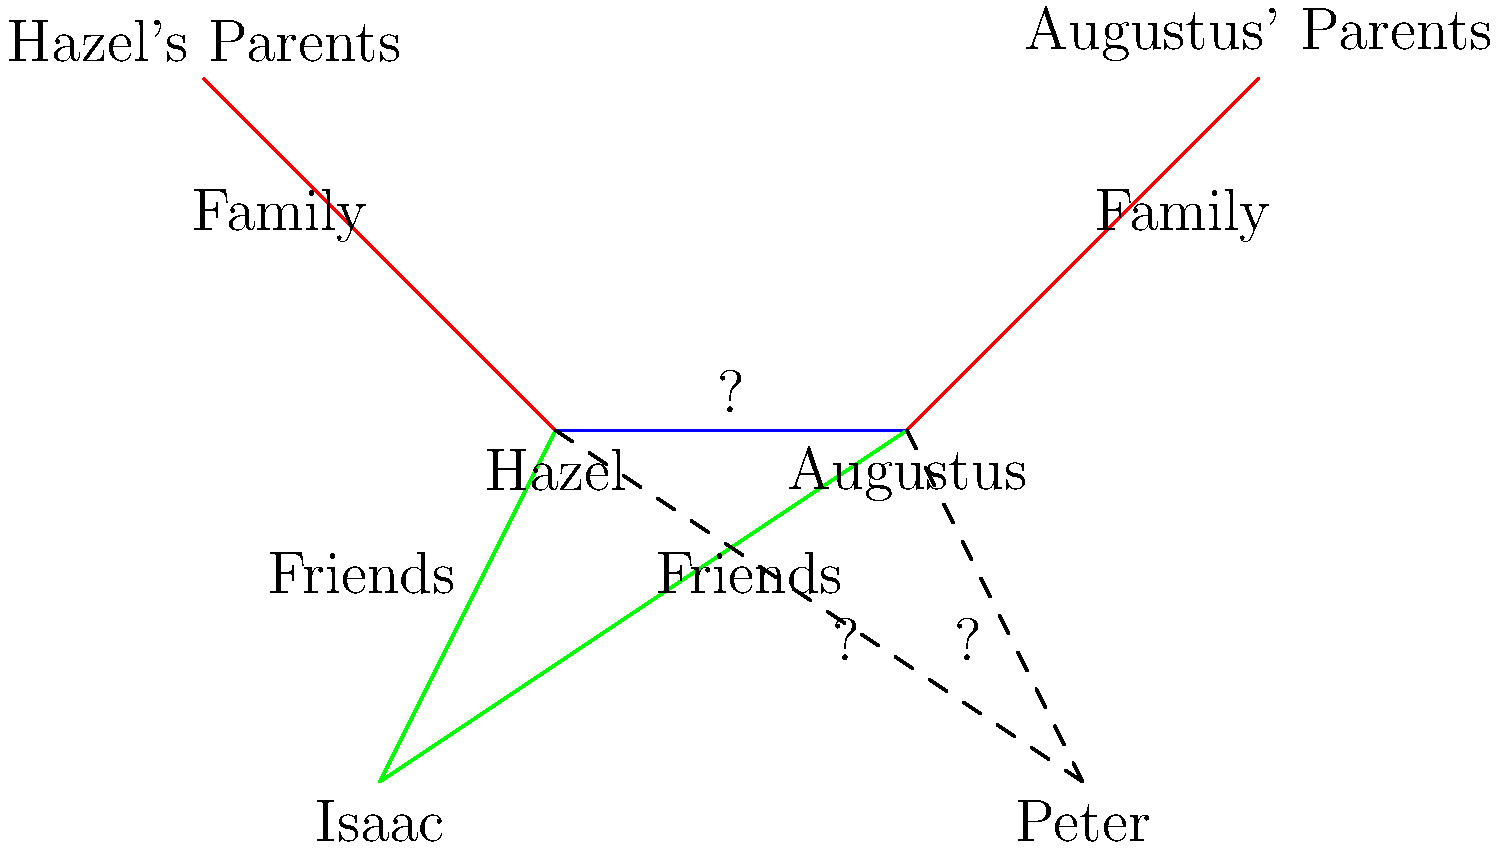In this infographic depicting character relationships in "The Fault in Our Stars," what is the most appropriate label for the connection between Hazel and Augustus, and how would you describe their relationship to Peter Van Houten? To answer this question, let's break down the relationships in "The Fault in Our Stars":

1. Hazel and Augustus:
   - They are the main characters and romantic interests.
   - Their relationship is central to the story's plot.
   - They share a deep emotional connection and fall in love.

2. Hazel/Augustus and Peter Van Houten:
   - Peter is the author of Hazel's favorite book, "An Imperial Affliction."
   - Hazel and Augustus travel to Amsterdam to meet Peter.
   - Their relationship with Peter is initially one of admiration, but becomes complicated after meeting him.
   - Peter disappoints them with his behavior, but still plays a significant role in their journey.

Given this information:

1. The connection between Hazel and Augustus should be labeled as "Love" or "Romance."
2. Their relationship to Peter Van Houten can be described as "Admirers/Disappointed fans."

The dashed lines in the infographic indicate a less direct or more complex relationship, which fits the nature of Hazel and Augustus's connection to Peter Van Houten.
Answer: Love; Admirers/Disappointed fans 